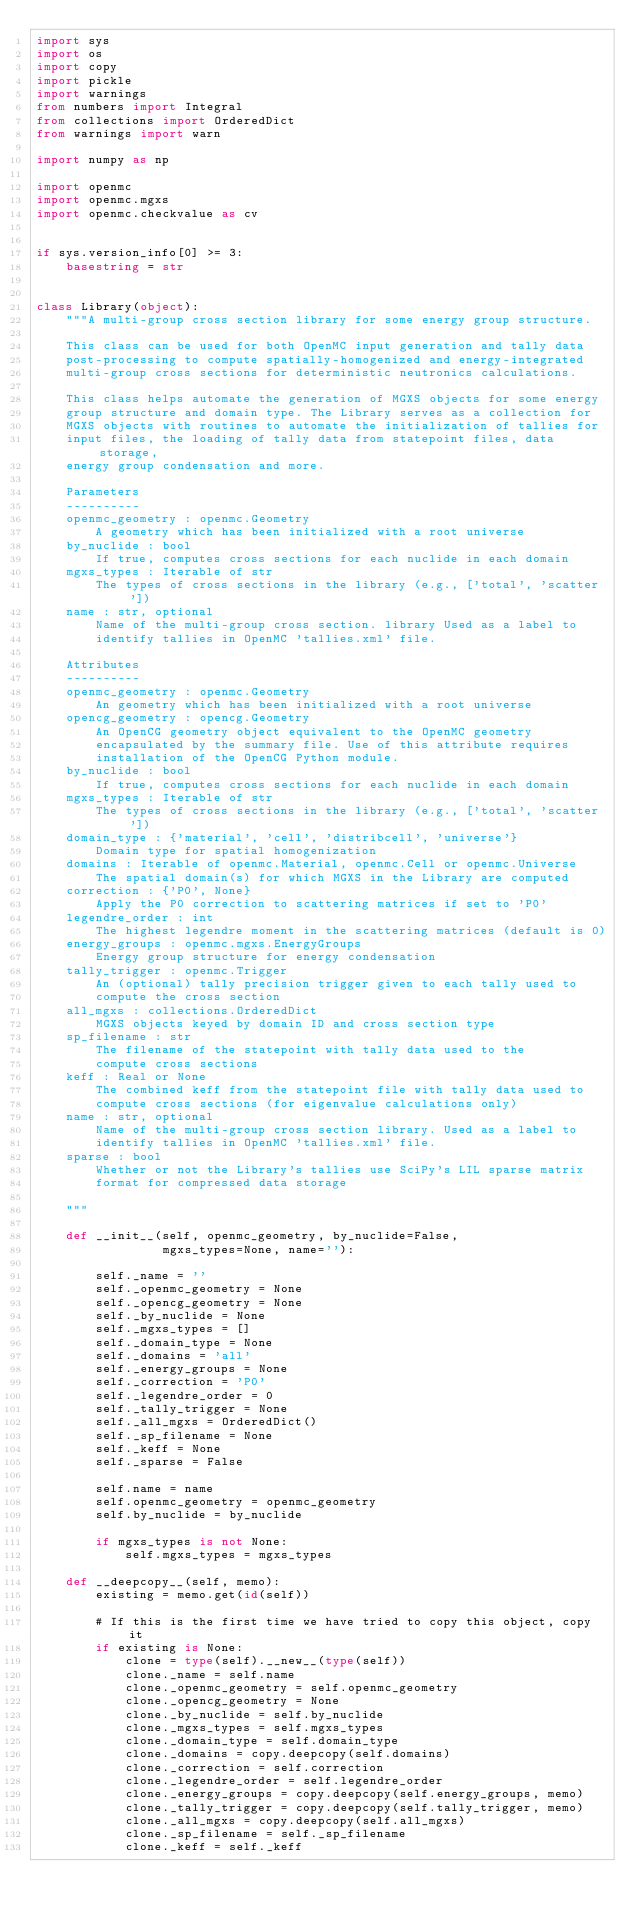Convert code to text. <code><loc_0><loc_0><loc_500><loc_500><_Python_>import sys
import os
import copy
import pickle
import warnings
from numbers import Integral
from collections import OrderedDict
from warnings import warn

import numpy as np

import openmc
import openmc.mgxs
import openmc.checkvalue as cv


if sys.version_info[0] >= 3:
    basestring = str


class Library(object):
    """A multi-group cross section library for some energy group structure.

    This class can be used for both OpenMC input generation and tally data
    post-processing to compute spatially-homogenized and energy-integrated
    multi-group cross sections for deterministic neutronics calculations.

    This class helps automate the generation of MGXS objects for some energy
    group structure and domain type. The Library serves as a collection for
    MGXS objects with routines to automate the initialization of tallies for
    input files, the loading of tally data from statepoint files, data storage,
    energy group condensation and more.

    Parameters
    ----------
    openmc_geometry : openmc.Geometry
        A geometry which has been initialized with a root universe
    by_nuclide : bool
        If true, computes cross sections for each nuclide in each domain
    mgxs_types : Iterable of str
        The types of cross sections in the library (e.g., ['total', 'scatter'])
    name : str, optional
        Name of the multi-group cross section. library Used as a label to
        identify tallies in OpenMC 'tallies.xml' file.

    Attributes
    ----------
    openmc_geometry : openmc.Geometry
        An geometry which has been initialized with a root universe
    opencg_geometry : opencg.Geometry
        An OpenCG geometry object equivalent to the OpenMC geometry
        encapsulated by the summary file. Use of this attribute requires
        installation of the OpenCG Python module.
    by_nuclide : bool
        If true, computes cross sections for each nuclide in each domain
    mgxs_types : Iterable of str
        The types of cross sections in the library (e.g., ['total', 'scatter'])
    domain_type : {'material', 'cell', 'distribcell', 'universe'}
        Domain type for spatial homogenization
    domains : Iterable of openmc.Material, openmc.Cell or openmc.Universe
        The spatial domain(s) for which MGXS in the Library are computed
    correction : {'P0', None}
        Apply the P0 correction to scattering matrices if set to 'P0'
    legendre_order : int
        The highest legendre moment in the scattering matrices (default is 0)
    energy_groups : openmc.mgxs.EnergyGroups
        Energy group structure for energy condensation
    tally_trigger : openmc.Trigger
        An (optional) tally precision trigger given to each tally used to
        compute the cross section
    all_mgxs : collections.OrderedDict
        MGXS objects keyed by domain ID and cross section type
    sp_filename : str
        The filename of the statepoint with tally data used to the
        compute cross sections
    keff : Real or None
        The combined keff from the statepoint file with tally data used to
        compute cross sections (for eigenvalue calculations only)
    name : str, optional
        Name of the multi-group cross section library. Used as a label to
        identify tallies in OpenMC 'tallies.xml' file.
    sparse : bool
        Whether or not the Library's tallies use SciPy's LIL sparse matrix
        format for compressed data storage

    """

    def __init__(self, openmc_geometry, by_nuclide=False,
                 mgxs_types=None, name=''):

        self._name = ''
        self._openmc_geometry = None
        self._opencg_geometry = None
        self._by_nuclide = None
        self._mgxs_types = []
        self._domain_type = None
        self._domains = 'all'
        self._energy_groups = None
        self._correction = 'P0'
        self._legendre_order = 0
        self._tally_trigger = None
        self._all_mgxs = OrderedDict()
        self._sp_filename = None
        self._keff = None
        self._sparse = False

        self.name = name
        self.openmc_geometry = openmc_geometry
        self.by_nuclide = by_nuclide

        if mgxs_types is not None:
            self.mgxs_types = mgxs_types

    def __deepcopy__(self, memo):
        existing = memo.get(id(self))

        # If this is the first time we have tried to copy this object, copy it
        if existing is None:
            clone = type(self).__new__(type(self))
            clone._name = self.name
            clone._openmc_geometry = self.openmc_geometry
            clone._opencg_geometry = None
            clone._by_nuclide = self.by_nuclide
            clone._mgxs_types = self.mgxs_types
            clone._domain_type = self.domain_type
            clone._domains = copy.deepcopy(self.domains)
            clone._correction = self.correction
            clone._legendre_order = self.legendre_order
            clone._energy_groups = copy.deepcopy(self.energy_groups, memo)
            clone._tally_trigger = copy.deepcopy(self.tally_trigger, memo)
            clone._all_mgxs = copy.deepcopy(self.all_mgxs)
            clone._sp_filename = self._sp_filename
            clone._keff = self._keff</code> 